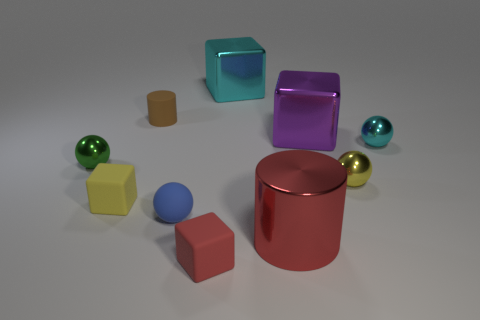What is the material of the cyan object that is the same size as the rubber cylinder?
Provide a succinct answer. Metal. How many other things are the same material as the cyan block?
Your response must be concise. 5. There is a tiny metallic thing that is on the left side of the large red cylinder; is its shape the same as the big object in front of the green sphere?
Your answer should be very brief. No. What number of other objects are the same color as the metallic cylinder?
Offer a terse response. 1. Is the cyan thing that is in front of the brown matte thing made of the same material as the ball in front of the tiny yellow cube?
Give a very brief answer. No. Are there an equal number of yellow matte objects in front of the blue ball and large metallic cylinders that are left of the yellow cube?
Offer a terse response. Yes. What material is the cyan thing behind the brown cylinder?
Make the answer very short. Metal. Is there any other thing that has the same size as the red rubber cube?
Provide a short and direct response. Yes. Is the number of yellow metallic balls less than the number of tiny blue metallic cylinders?
Provide a succinct answer. No. There is a thing that is both left of the tiny blue matte ball and behind the large purple shiny object; what is its shape?
Give a very brief answer. Cylinder. 